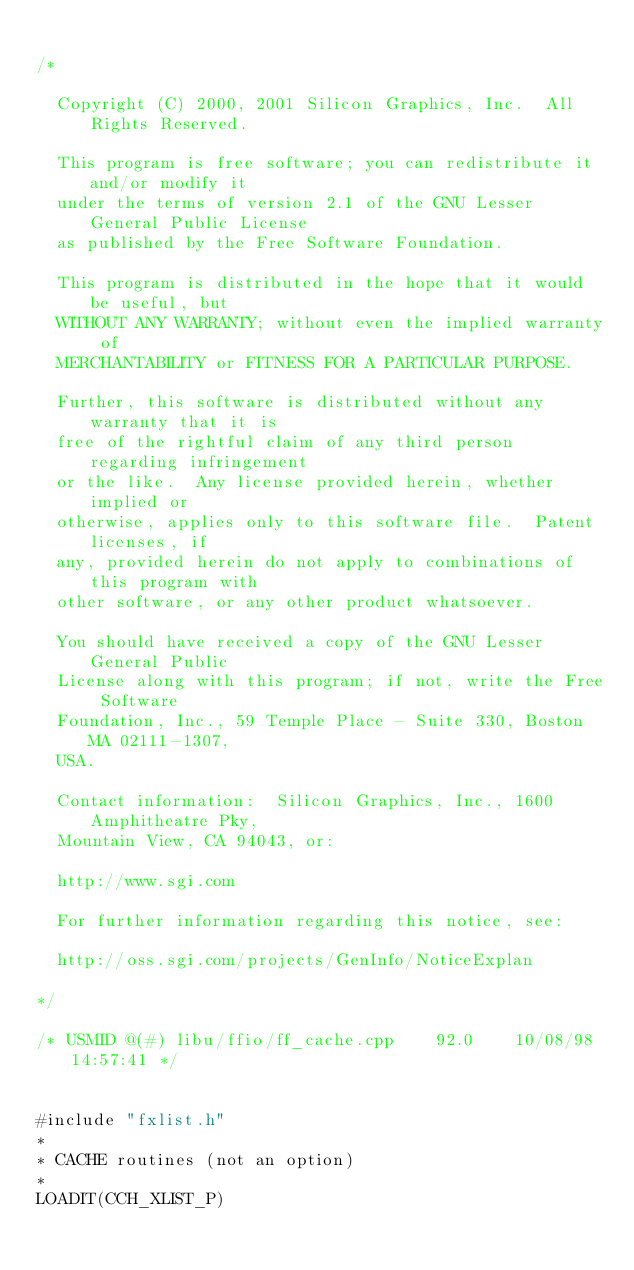Convert code to text. <code><loc_0><loc_0><loc_500><loc_500><_C++_>
/*

  Copyright (C) 2000, 2001 Silicon Graphics, Inc.  All Rights Reserved.

  This program is free software; you can redistribute it and/or modify it
  under the terms of version 2.1 of the GNU Lesser General Public License 
  as published by the Free Software Foundation.

  This program is distributed in the hope that it would be useful, but
  WITHOUT ANY WARRANTY; without even the implied warranty of
  MERCHANTABILITY or FITNESS FOR A PARTICULAR PURPOSE.  

  Further, this software is distributed without any warranty that it is
  free of the rightful claim of any third person regarding infringement 
  or the like.  Any license provided herein, whether implied or 
  otherwise, applies only to this software file.  Patent licenses, if
  any, provided herein do not apply to combinations of this program with 
  other software, or any other product whatsoever.  

  You should have received a copy of the GNU Lesser General Public 
  License along with this program; if not, write the Free Software 
  Foundation, Inc., 59 Temple Place - Suite 330, Boston MA 02111-1307, 
  USA.

  Contact information:  Silicon Graphics, Inc., 1600 Amphitheatre Pky,
  Mountain View, CA 94043, or:

  http://www.sgi.com

  For further information regarding this notice, see:

  http://oss.sgi.com/projects/GenInfo/NoticeExplan

*/

/* USMID @(#) libu/ffio/ff_cache.cpp	92.0	10/08/98 14:57:41 */


#include "fxlist.h"
*
* CACHE routines (not an option)
*
LOADIT(CCH_XLIST_P)
</code> 